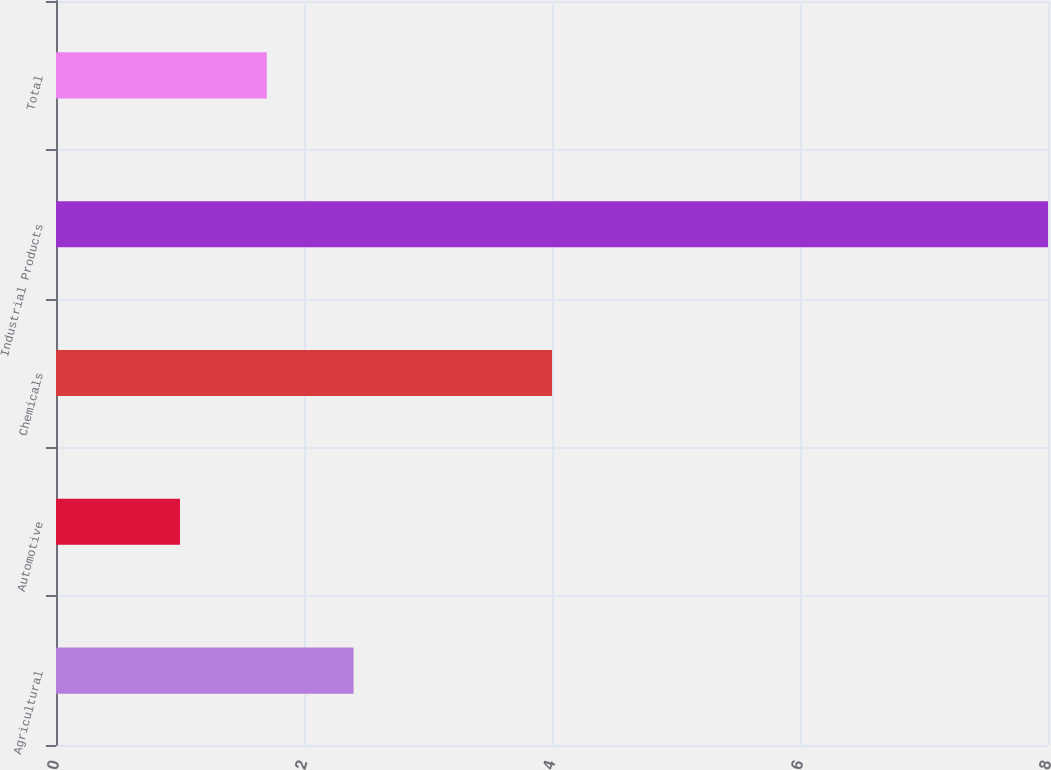Convert chart to OTSL. <chart><loc_0><loc_0><loc_500><loc_500><bar_chart><fcel>Agricultural<fcel>Automotive<fcel>Chemicals<fcel>Industrial Products<fcel>Total<nl><fcel>2.4<fcel>1<fcel>4<fcel>8<fcel>1.7<nl></chart> 